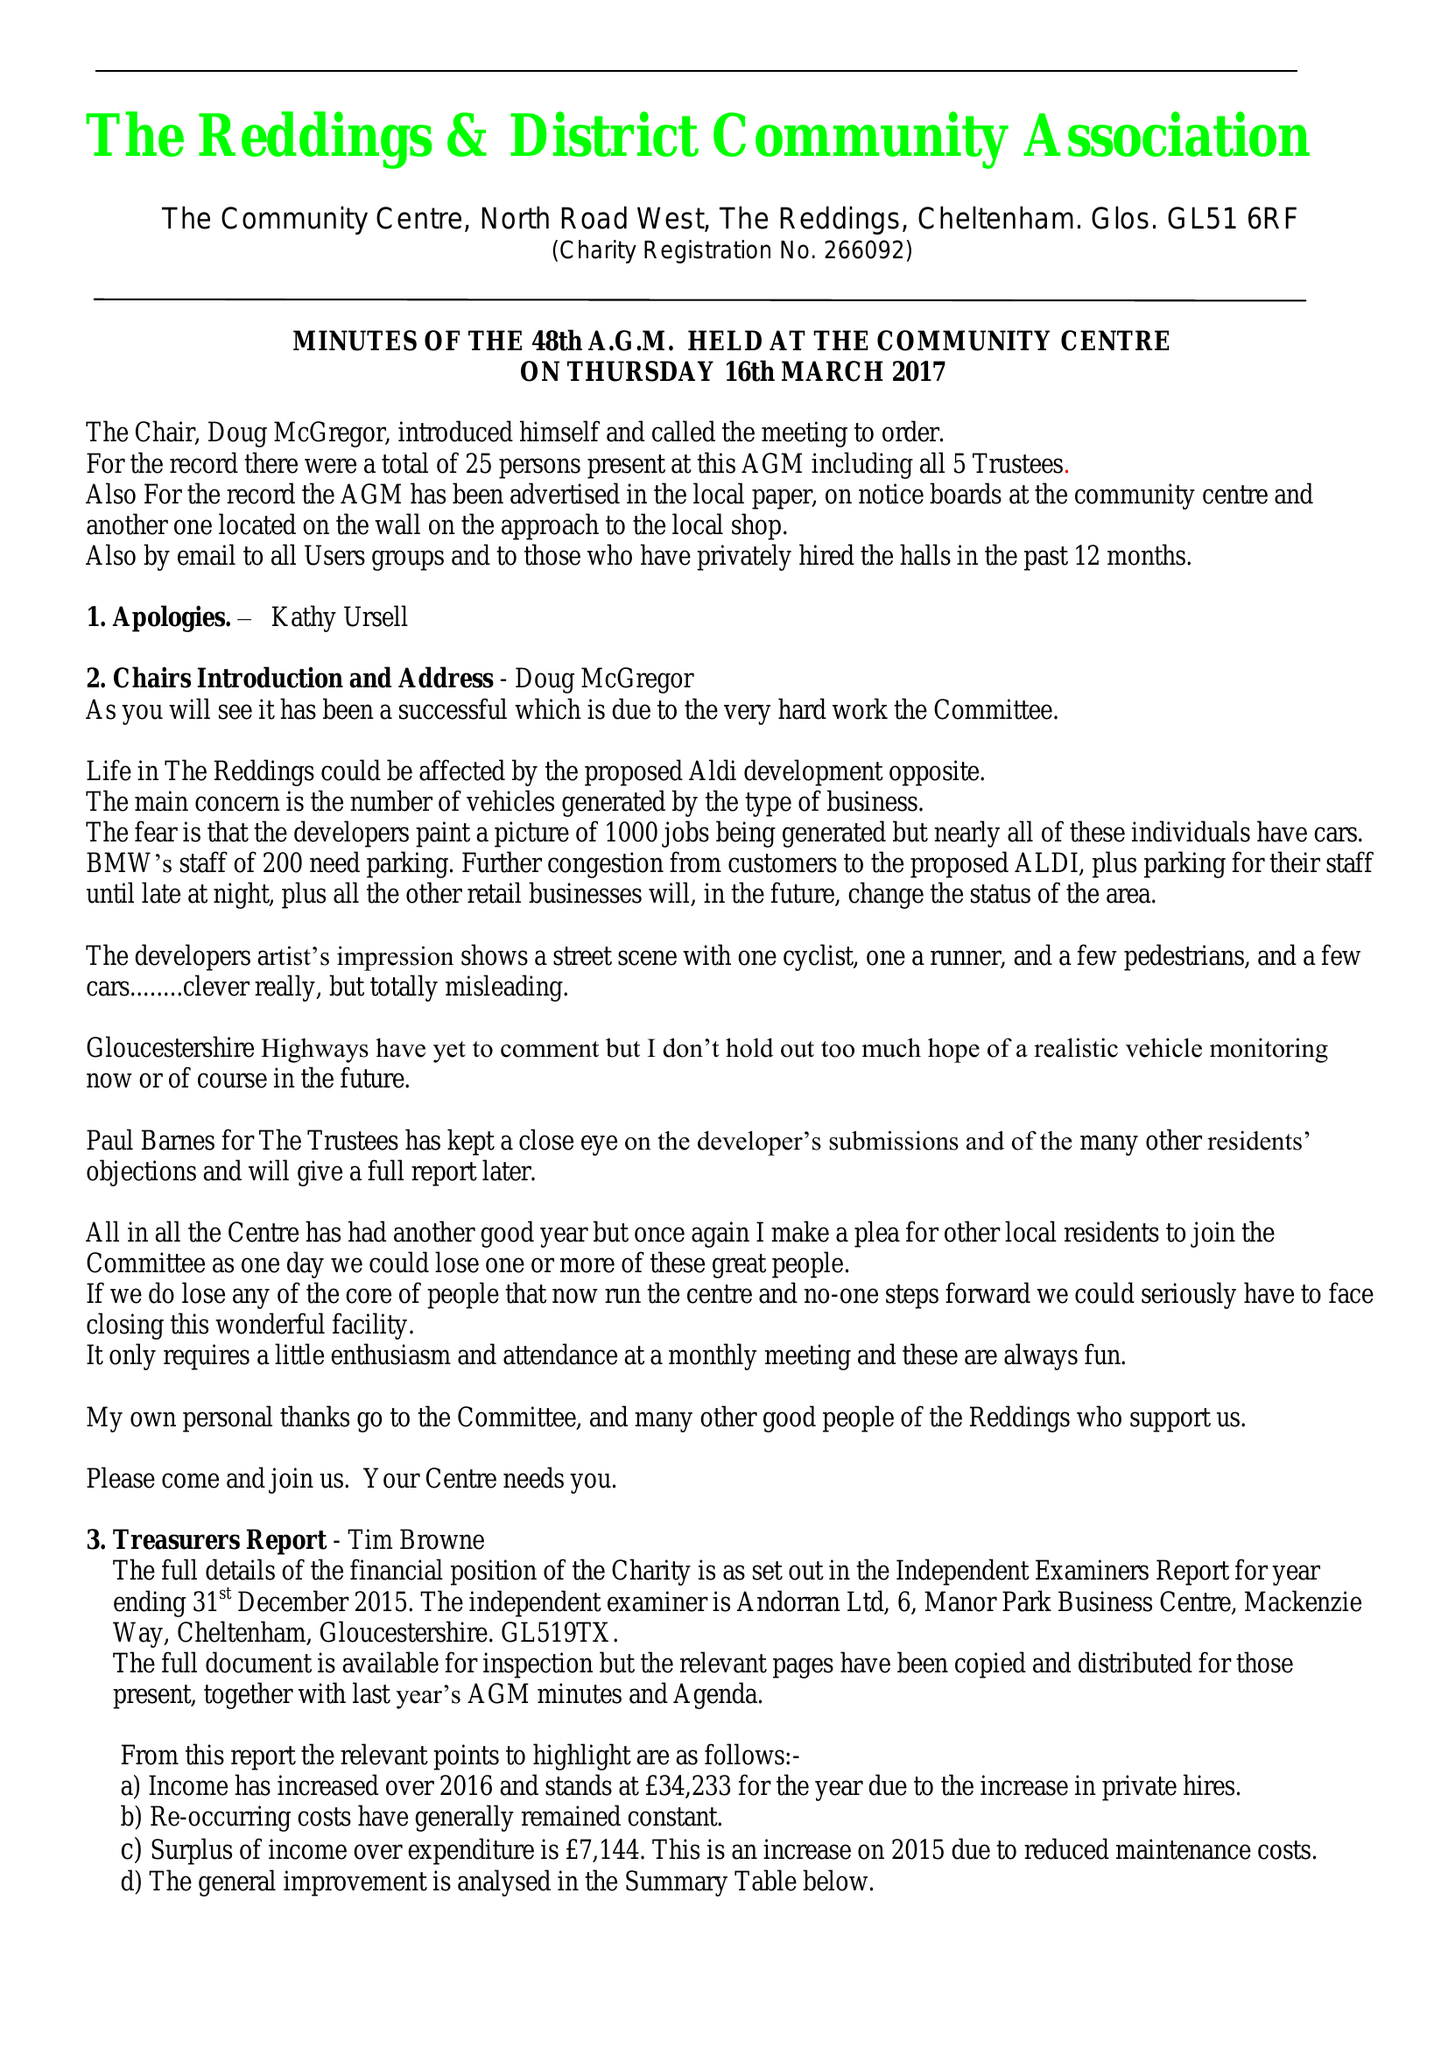What is the value for the income_annually_in_british_pounds?
Answer the question using a single word or phrase. 34233.00 